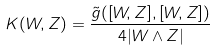Convert formula to latex. <formula><loc_0><loc_0><loc_500><loc_500>K ( W , Z ) = \frac { \tilde { g } ( [ W , Z ] , [ W , Z ] ) } { 4 | W \wedge Z | }</formula> 